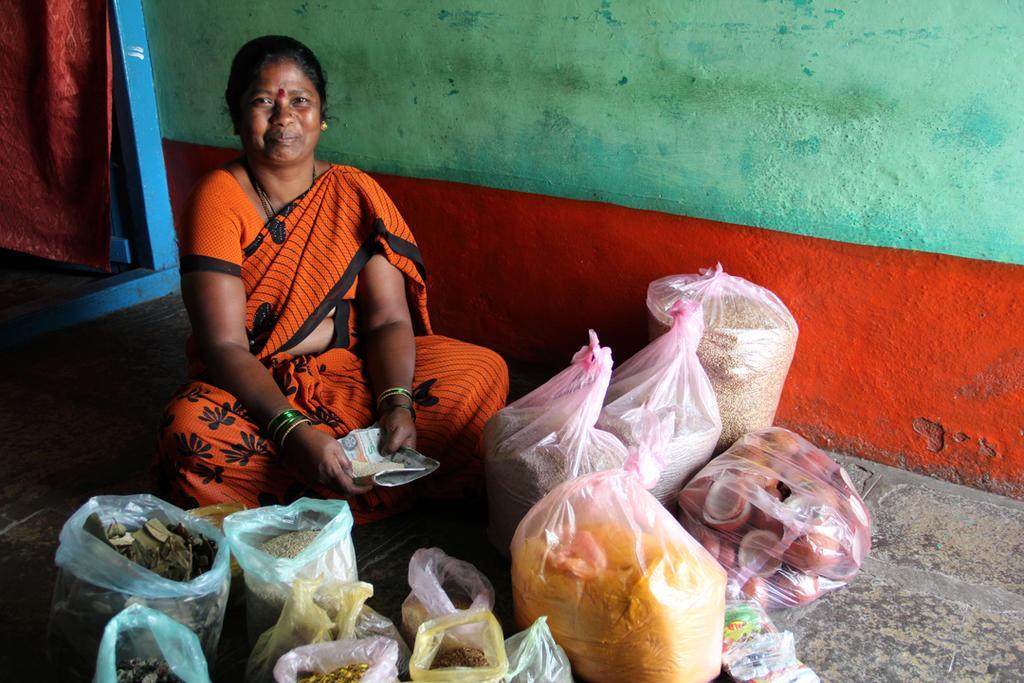Describe this image in one or two sentences. In this image we can see a lady is sitting on the floor. In front of her so many things are present. Behind green and orange color wall is there and blue color door is present with curtain. 